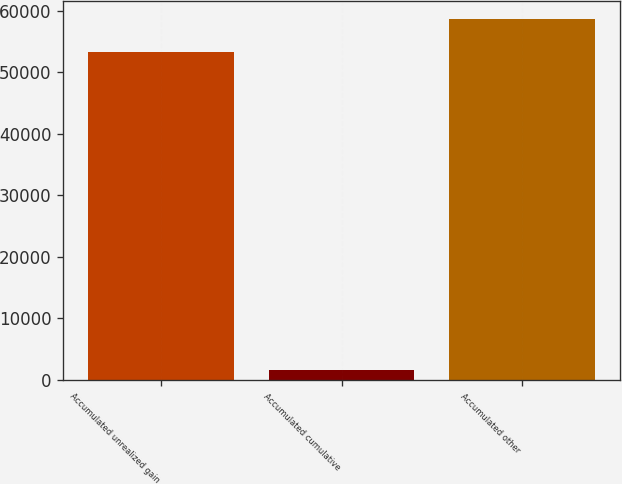Convert chart to OTSL. <chart><loc_0><loc_0><loc_500><loc_500><bar_chart><fcel>Accumulated unrealized gain<fcel>Accumulated cumulative<fcel>Accumulated other<nl><fcel>53375<fcel>1689<fcel>58712.5<nl></chart> 